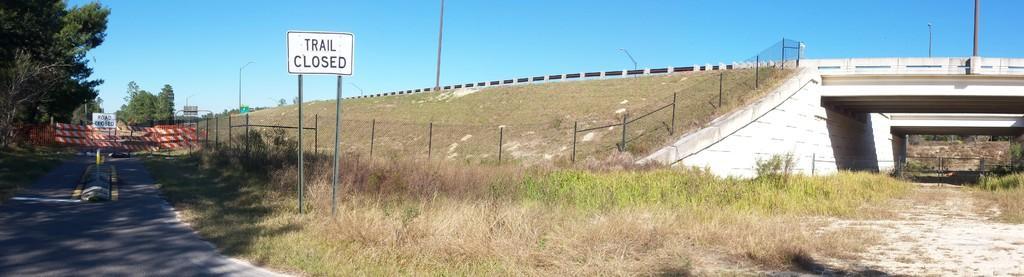Can you describe this image briefly? This image consists of grass in the middle. There is a bridge in the middle. There is sky at the top. There are trees on the left side. 